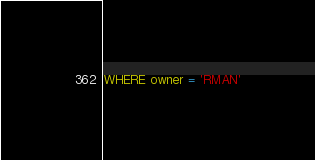<code> <loc_0><loc_0><loc_500><loc_500><_SQL_>WHERE owner = 'RMAN'</code> 